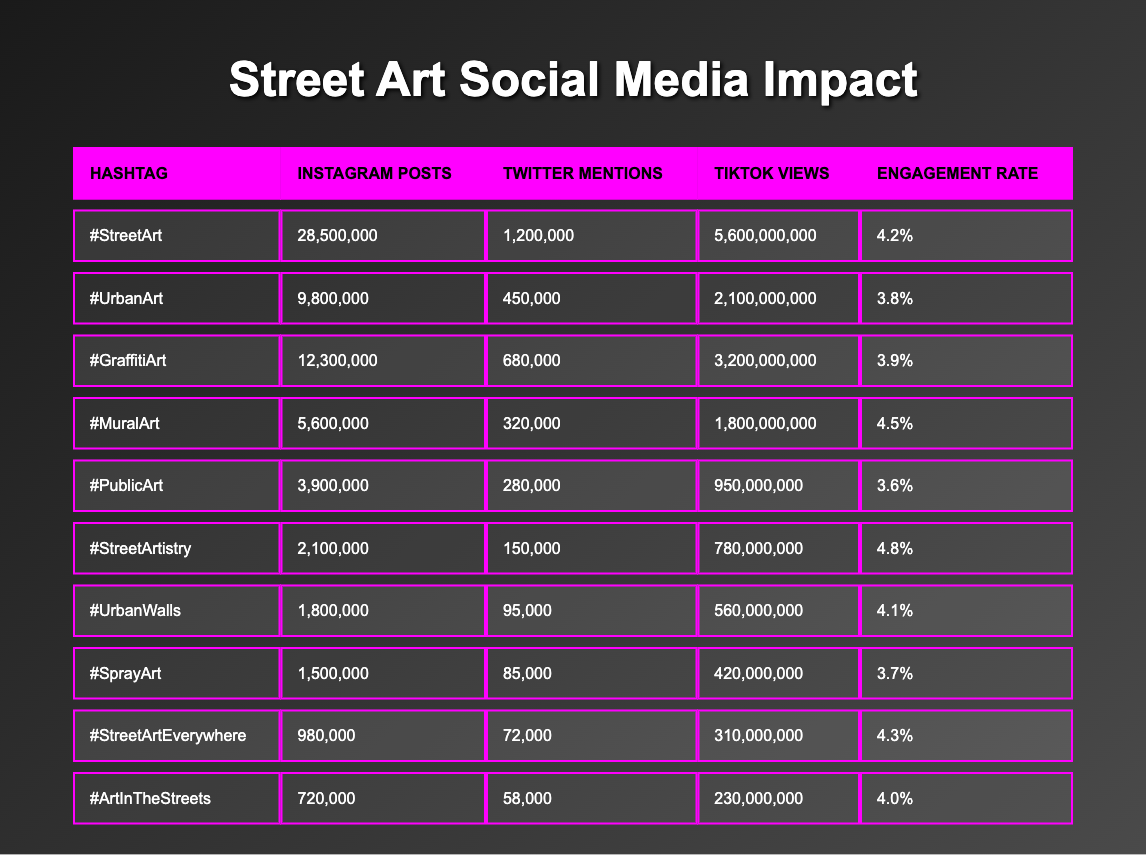What is the highest number of Instagram posts among the hashtags? By looking at the table, the highest number of Instagram posts is 28,500,000, associated with the hashtag #StreetArt.
Answer: 28,500,000 Which hashtag has the lowest engagement rate? The engagement rates are as follows: #StreetArt (4.2%), #UrbanArt (3.8%), #GraffitiArt (3.9%), #MuralArt (4.5%), #PublicArt (3.6%), #StreetArtistry (4.8%), #UrbanWalls (4.1%), #SprayArt (3.7%), #StreetArtEverywhere (4.3%), #ArtInTheStreets (4.0%). The lowest rate is 3.6% for #PublicArt.
Answer: #PublicArt What is the total number of Twitter mentions for #GraffitiArt and #UrbanArt combined? The number of Twitter mentions for #GraffitiArt is 680,000 and for #UrbanArt is 450,000. When combined, that is 680,000 + 450,000 = 1,130,000.
Answer: 1,130,000 Is the number of TikTok views for #MuralArt greater than for #UrbanWalls? The number of TikTok views for #MuralArt is 1,800,000,000 and for #UrbanWalls is 560,000,000. Since 1,800,000,000 is greater than 560,000,000, the statement is true.
Answer: Yes What is the average engagement rate of the hashtags listed? To find the average engagement rate, we take the rates: 4.2%, 3.8%, 3.9%, 4.5%, 3.6%, 4.8%, 4.1%, 3.7%, 4.3%, 4.0%. Summing these gives 43.9%. Dividing by 10 gives an average engagement rate of 4.39%.
Answer: 4.39% 